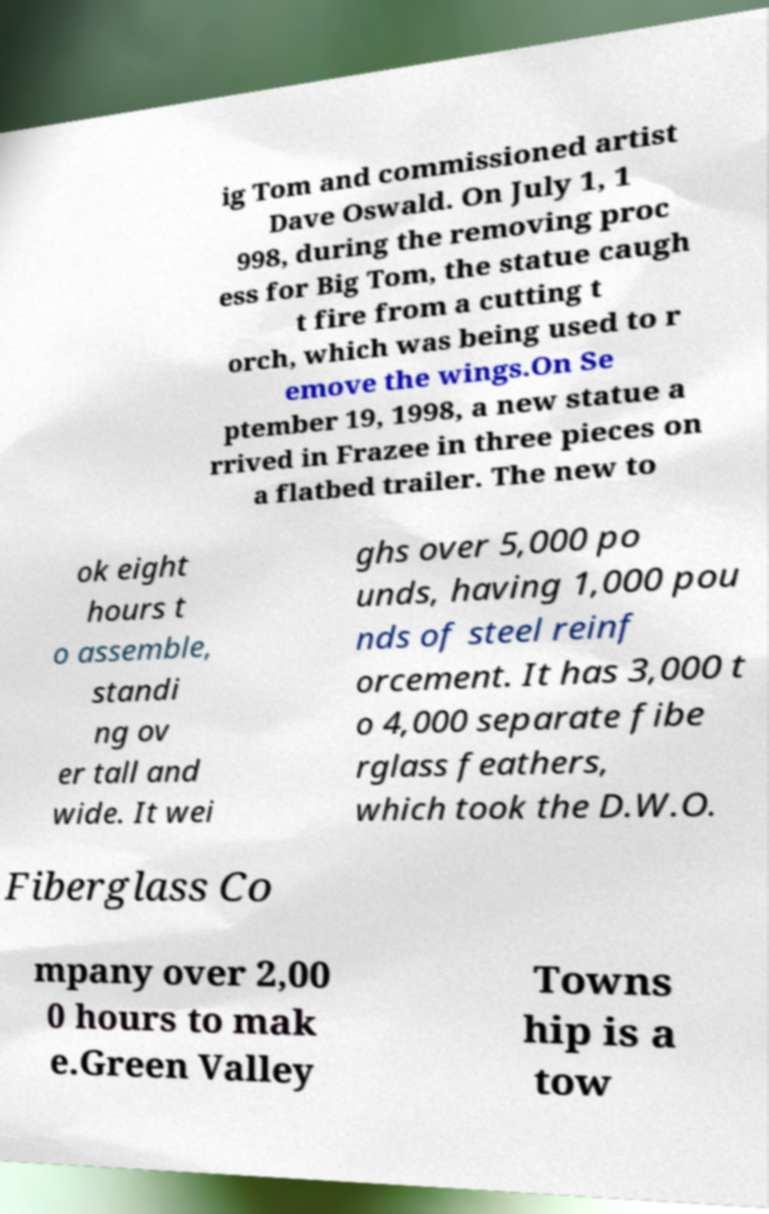Could you extract and type out the text from this image? ig Tom and commissioned artist Dave Oswald. On July 1, 1 998, during the removing proc ess for Big Tom, the statue caugh t fire from a cutting t orch, which was being used to r emove the wings.On Se ptember 19, 1998, a new statue a rrived in Frazee in three pieces on a flatbed trailer. The new to ok eight hours t o assemble, standi ng ov er tall and wide. It wei ghs over 5,000 po unds, having 1,000 pou nds of steel reinf orcement. It has 3,000 t o 4,000 separate fibe rglass feathers, which took the D.W.O. Fiberglass Co mpany over 2,00 0 hours to mak e.Green Valley Towns hip is a tow 